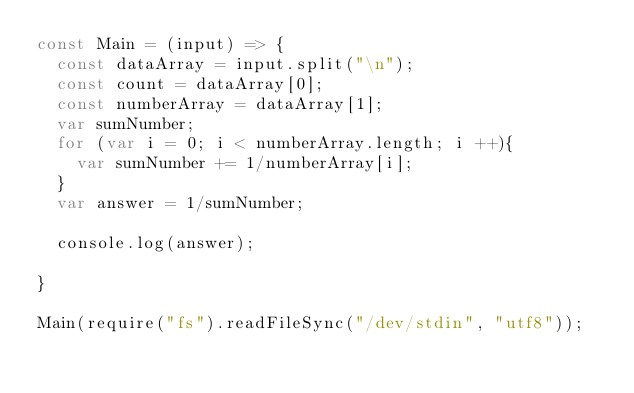<code> <loc_0><loc_0><loc_500><loc_500><_JavaScript_>const Main = (input) => {
  const dataArray = input.split("\n");
  const count = dataArray[0];
  const numberArray = dataArray[1];
  var sumNumber;
  for (var i = 0; i < numberArray.length; i ++){
  	var sumNumber += 1/numberArray[i];
  }
  var answer = 1/sumNumber;
  
  console.log(answer);
  
}

Main(require("fs").readFileSync("/dev/stdin", "utf8"));</code> 